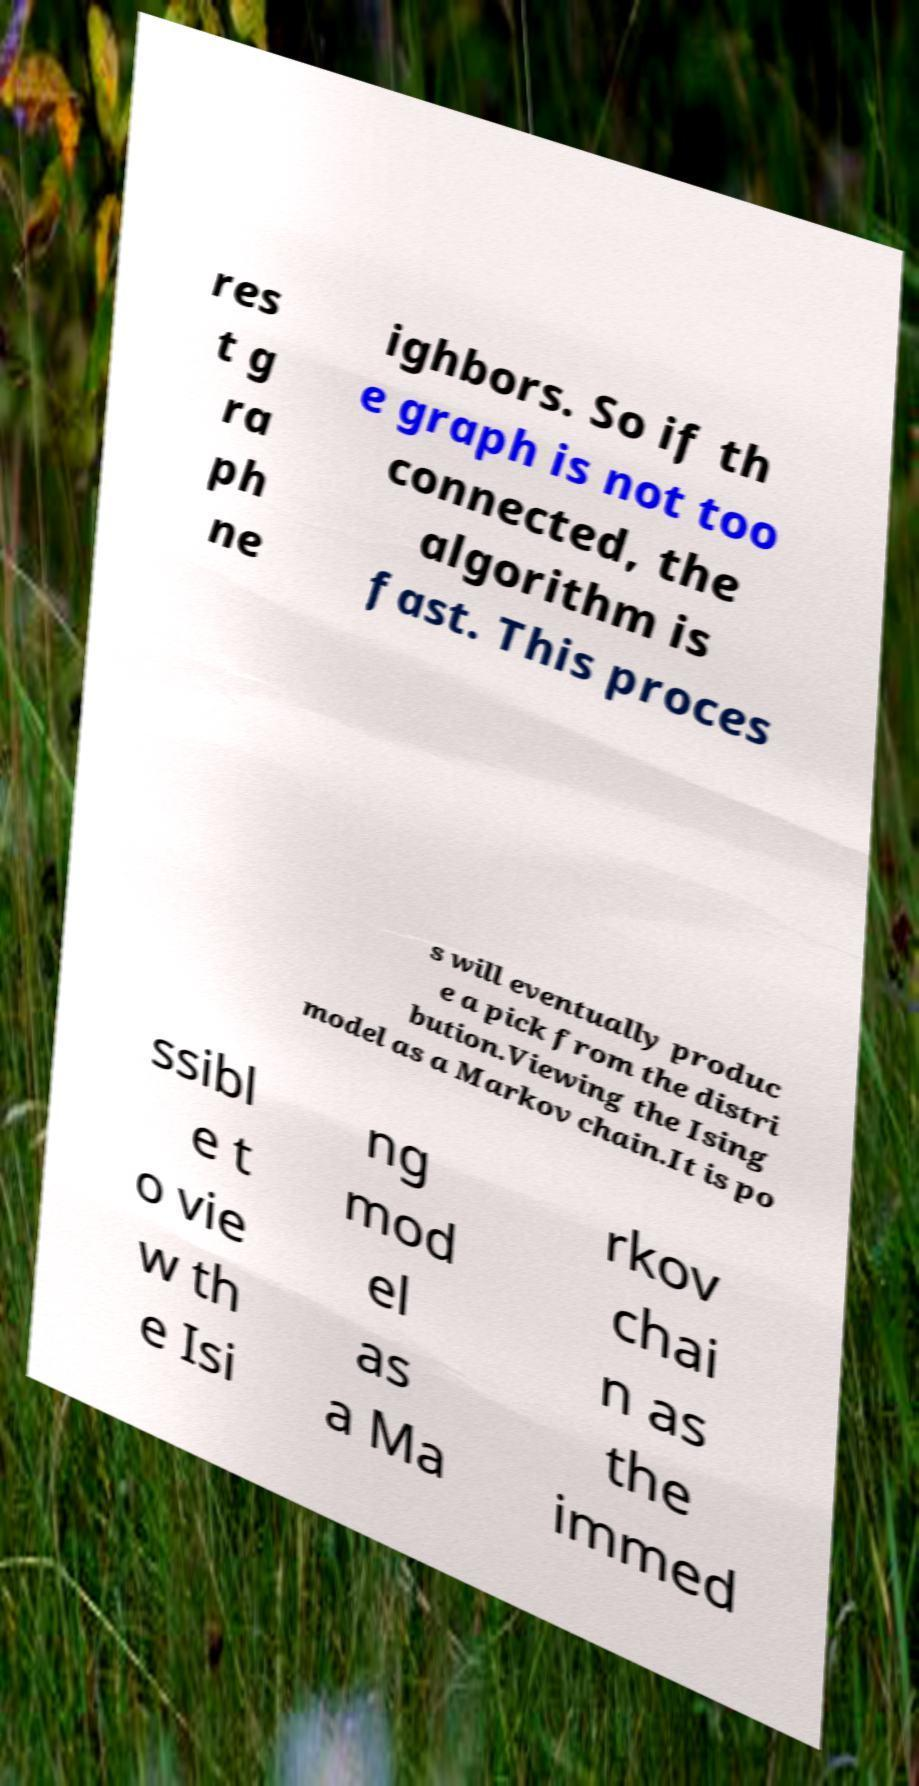Could you extract and type out the text from this image? res t g ra ph ne ighbors. So if th e graph is not too connected, the algorithm is fast. This proces s will eventually produc e a pick from the distri bution.Viewing the Ising model as a Markov chain.It is po ssibl e t o vie w th e Isi ng mod el as a Ma rkov chai n as the immed 